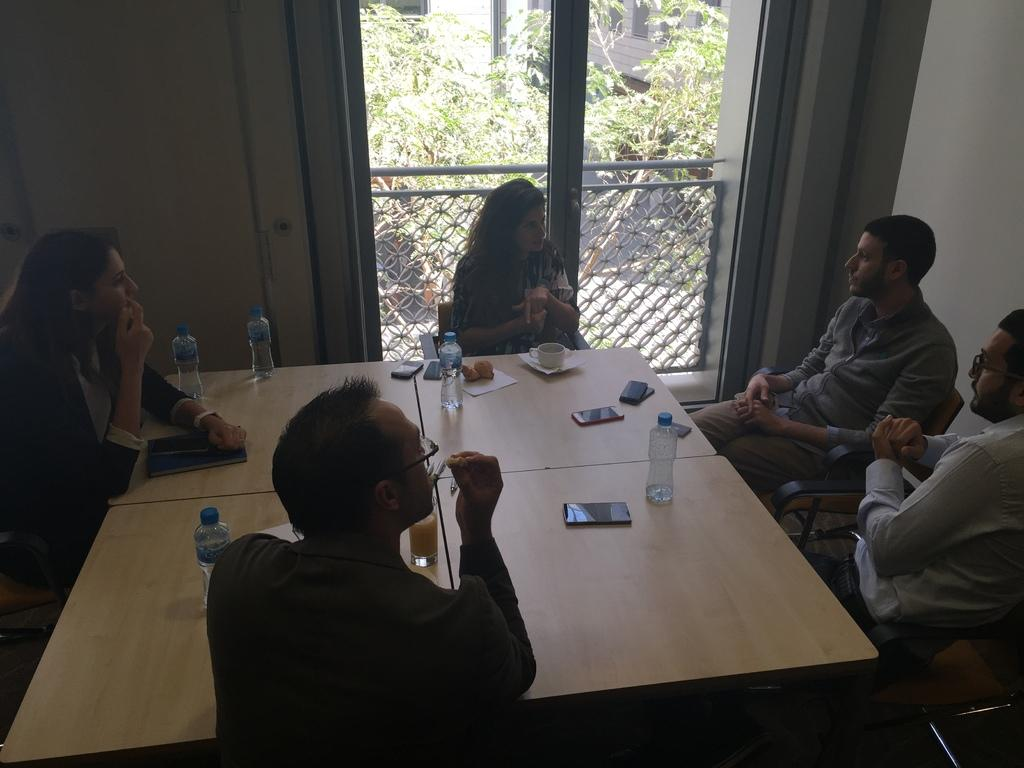What are the people in the image doing? The people in the image are sitting around a table. What objects can be seen on the table? There are mobile phones, papers, a cup, and bottles on the table. What is visible behind the woman in the image? There are trees and a fence visible behind the woman. Can you tell me how many horses are visible in the image? There are no horses present in the image. What type of bear can be seen interacting with the people at the table? There is no bear present in the image; the people are sitting around a table with various objects. 